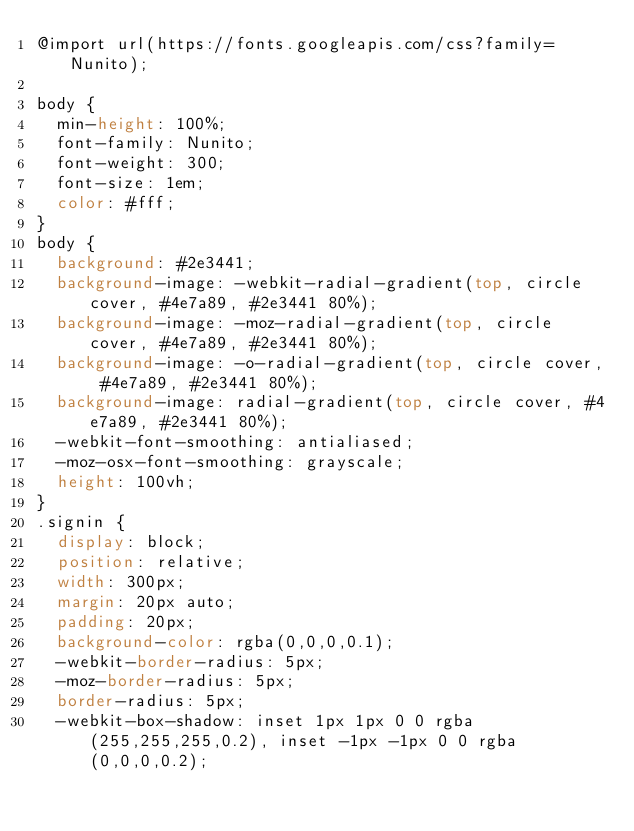Convert code to text. <code><loc_0><loc_0><loc_500><loc_500><_CSS_>@import url(https://fonts.googleapis.com/css?family=Nunito);

body {
  min-height: 100%;
  font-family: Nunito;
  font-weight: 300;
  font-size: 1em;
  color: #fff;
}
body {
  background: #2e3441;
  background-image: -webkit-radial-gradient(top, circle cover, #4e7a89, #2e3441 80%);
  background-image: -moz-radial-gradient(top, circle cover, #4e7a89, #2e3441 80%);
  background-image: -o-radial-gradient(top, circle cover, #4e7a89, #2e3441 80%);
  background-image: radial-gradient(top, circle cover, #4e7a89, #2e3441 80%);
  -webkit-font-smoothing: antialiased;
  -moz-osx-font-smoothing: grayscale;
  height: 100vh;
}
.signin {
  display: block;
  position: relative;
  width: 300px;
  margin: 20px auto;
  padding: 20px;
  background-color: rgba(0,0,0,0.1);
  -webkit-border-radius: 5px;
  -moz-border-radius: 5px;
  border-radius: 5px;
  -webkit-box-shadow: inset 1px 1px 0 0 rgba(255,255,255,0.2), inset -1px -1px 0 0 rgba(0,0,0,0.2);</code> 